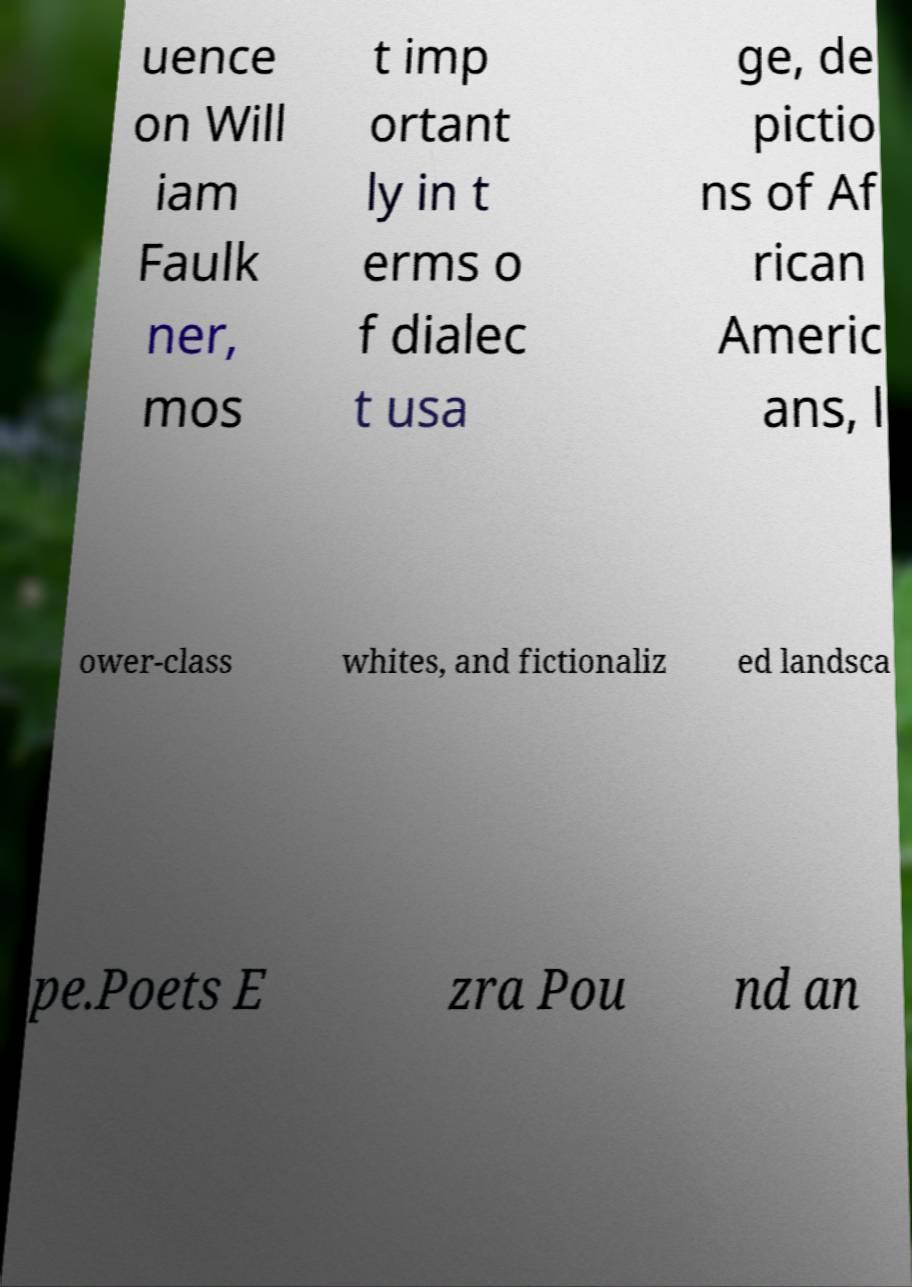There's text embedded in this image that I need extracted. Can you transcribe it verbatim? uence on Will iam Faulk ner, mos t imp ortant ly in t erms o f dialec t usa ge, de pictio ns of Af rican Americ ans, l ower-class whites, and fictionaliz ed landsca pe.Poets E zra Pou nd an 